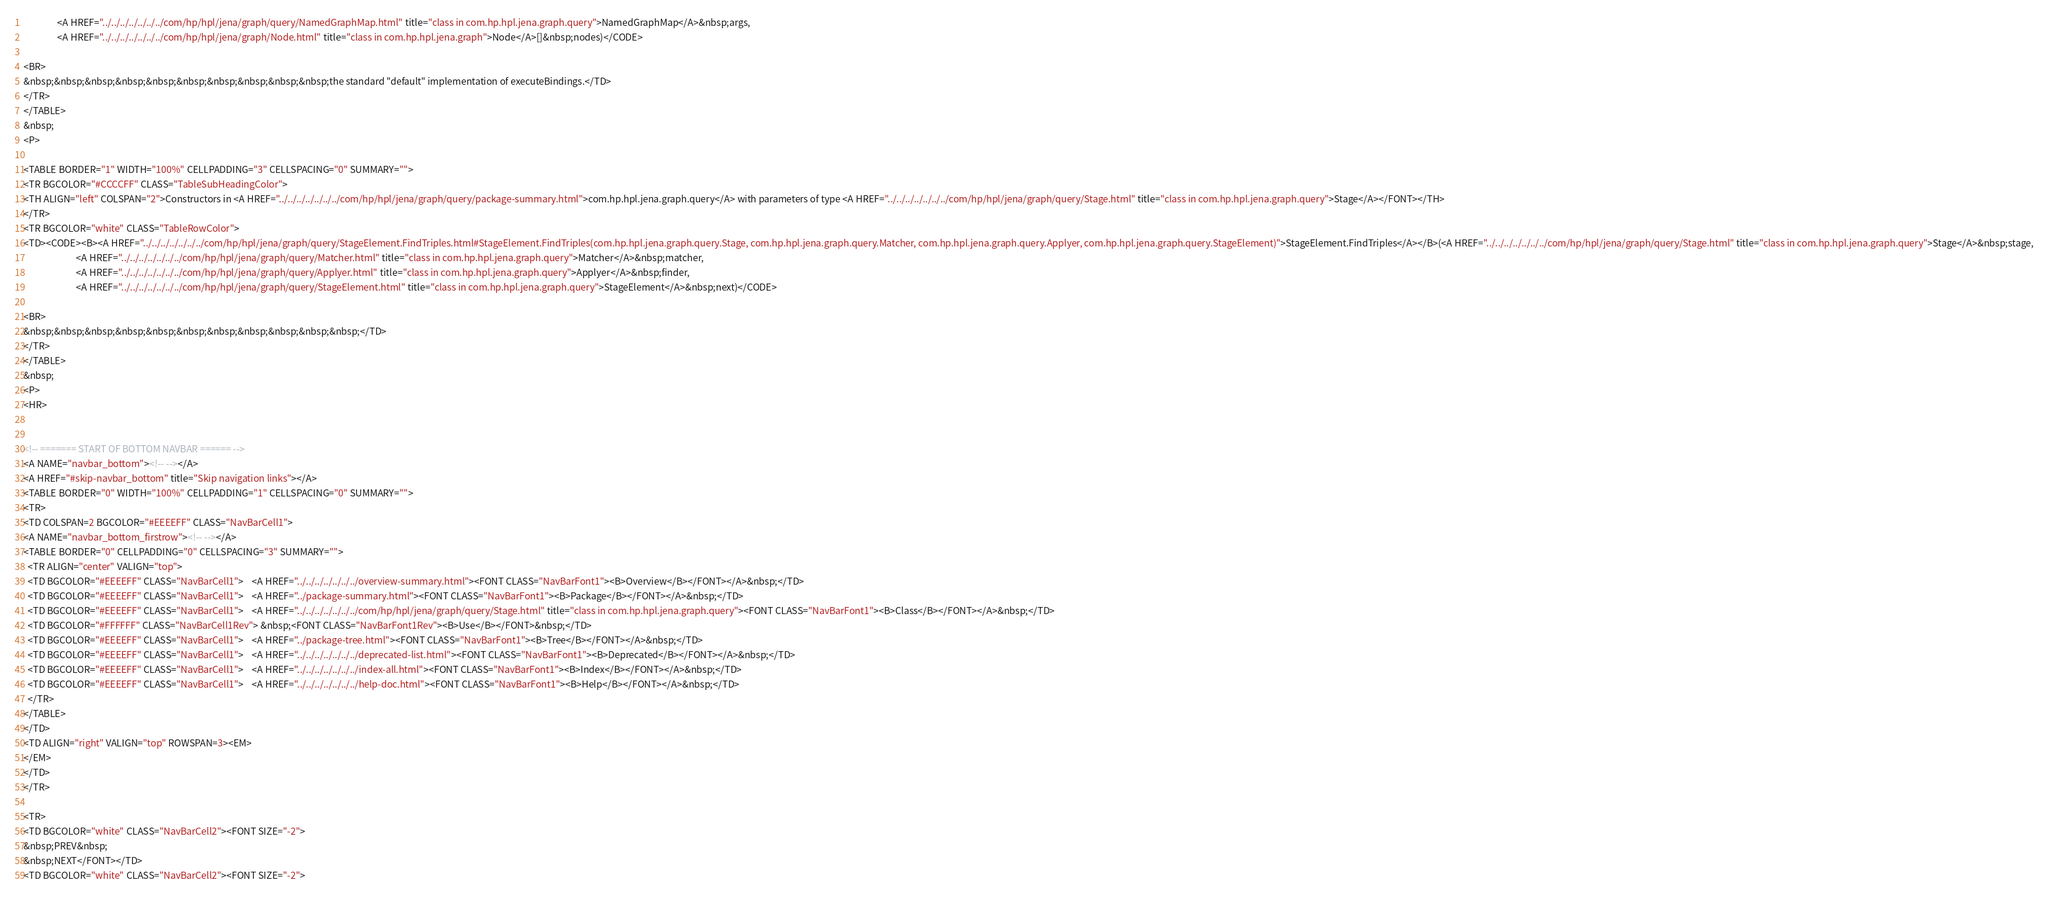<code> <loc_0><loc_0><loc_500><loc_500><_HTML_>                <A HREF="../../../../../../../com/hp/hpl/jena/graph/query/NamedGraphMap.html" title="class in com.hp.hpl.jena.graph.query">NamedGraphMap</A>&nbsp;args,
                <A HREF="../../../../../../../com/hp/hpl/jena/graph/Node.html" title="class in com.hp.hpl.jena.graph">Node</A>[]&nbsp;nodes)</CODE>

<BR>
&nbsp;&nbsp;&nbsp;&nbsp;&nbsp;&nbsp;&nbsp;&nbsp;&nbsp;&nbsp;the standard "default" implementation of executeBindings.</TD>
</TR>
</TABLE>
&nbsp;
<P>

<TABLE BORDER="1" WIDTH="100%" CELLPADDING="3" CELLSPACING="0" SUMMARY="">
<TR BGCOLOR="#CCCCFF" CLASS="TableSubHeadingColor">
<TH ALIGN="left" COLSPAN="2">Constructors in <A HREF="../../../../../../../com/hp/hpl/jena/graph/query/package-summary.html">com.hp.hpl.jena.graph.query</A> with parameters of type <A HREF="../../../../../../../com/hp/hpl/jena/graph/query/Stage.html" title="class in com.hp.hpl.jena.graph.query">Stage</A></FONT></TH>
</TR>
<TR BGCOLOR="white" CLASS="TableRowColor">
<TD><CODE><B><A HREF="../../../../../../../com/hp/hpl/jena/graph/query/StageElement.FindTriples.html#StageElement.FindTriples(com.hp.hpl.jena.graph.query.Stage, com.hp.hpl.jena.graph.query.Matcher, com.hp.hpl.jena.graph.query.Applyer, com.hp.hpl.jena.graph.query.StageElement)">StageElement.FindTriples</A></B>(<A HREF="../../../../../../../com/hp/hpl/jena/graph/query/Stage.html" title="class in com.hp.hpl.jena.graph.query">Stage</A>&nbsp;stage,
                         <A HREF="../../../../../../../com/hp/hpl/jena/graph/query/Matcher.html" title="class in com.hp.hpl.jena.graph.query">Matcher</A>&nbsp;matcher,
                         <A HREF="../../../../../../../com/hp/hpl/jena/graph/query/Applyer.html" title="class in com.hp.hpl.jena.graph.query">Applyer</A>&nbsp;finder,
                         <A HREF="../../../../../../../com/hp/hpl/jena/graph/query/StageElement.html" title="class in com.hp.hpl.jena.graph.query">StageElement</A>&nbsp;next)</CODE>

<BR>
&nbsp;&nbsp;&nbsp;&nbsp;&nbsp;&nbsp;&nbsp;&nbsp;&nbsp;&nbsp;&nbsp;</TD>
</TR>
</TABLE>
&nbsp;
<P>
<HR>


<!-- ======= START OF BOTTOM NAVBAR ====== -->
<A NAME="navbar_bottom"><!-- --></A>
<A HREF="#skip-navbar_bottom" title="Skip navigation links"></A>
<TABLE BORDER="0" WIDTH="100%" CELLPADDING="1" CELLSPACING="0" SUMMARY="">
<TR>
<TD COLSPAN=2 BGCOLOR="#EEEEFF" CLASS="NavBarCell1">
<A NAME="navbar_bottom_firstrow"><!-- --></A>
<TABLE BORDER="0" CELLPADDING="0" CELLSPACING="3" SUMMARY="">
  <TR ALIGN="center" VALIGN="top">
  <TD BGCOLOR="#EEEEFF" CLASS="NavBarCell1">    <A HREF="../../../../../../../overview-summary.html"><FONT CLASS="NavBarFont1"><B>Overview</B></FONT></A>&nbsp;</TD>
  <TD BGCOLOR="#EEEEFF" CLASS="NavBarCell1">    <A HREF="../package-summary.html"><FONT CLASS="NavBarFont1"><B>Package</B></FONT></A>&nbsp;</TD>
  <TD BGCOLOR="#EEEEFF" CLASS="NavBarCell1">    <A HREF="../../../../../../../com/hp/hpl/jena/graph/query/Stage.html" title="class in com.hp.hpl.jena.graph.query"><FONT CLASS="NavBarFont1"><B>Class</B></FONT></A>&nbsp;</TD>
  <TD BGCOLOR="#FFFFFF" CLASS="NavBarCell1Rev"> &nbsp;<FONT CLASS="NavBarFont1Rev"><B>Use</B></FONT>&nbsp;</TD>
  <TD BGCOLOR="#EEEEFF" CLASS="NavBarCell1">    <A HREF="../package-tree.html"><FONT CLASS="NavBarFont1"><B>Tree</B></FONT></A>&nbsp;</TD>
  <TD BGCOLOR="#EEEEFF" CLASS="NavBarCell1">    <A HREF="../../../../../../../deprecated-list.html"><FONT CLASS="NavBarFont1"><B>Deprecated</B></FONT></A>&nbsp;</TD>
  <TD BGCOLOR="#EEEEFF" CLASS="NavBarCell1">    <A HREF="../../../../../../../index-all.html"><FONT CLASS="NavBarFont1"><B>Index</B></FONT></A>&nbsp;</TD>
  <TD BGCOLOR="#EEEEFF" CLASS="NavBarCell1">    <A HREF="../../../../../../../help-doc.html"><FONT CLASS="NavBarFont1"><B>Help</B></FONT></A>&nbsp;</TD>
  </TR>
</TABLE>
</TD>
<TD ALIGN="right" VALIGN="top" ROWSPAN=3><EM>
</EM>
</TD>
</TR>

<TR>
<TD BGCOLOR="white" CLASS="NavBarCell2"><FONT SIZE="-2">
&nbsp;PREV&nbsp;
&nbsp;NEXT</FONT></TD>
<TD BGCOLOR="white" CLASS="NavBarCell2"><FONT SIZE="-2"></code> 